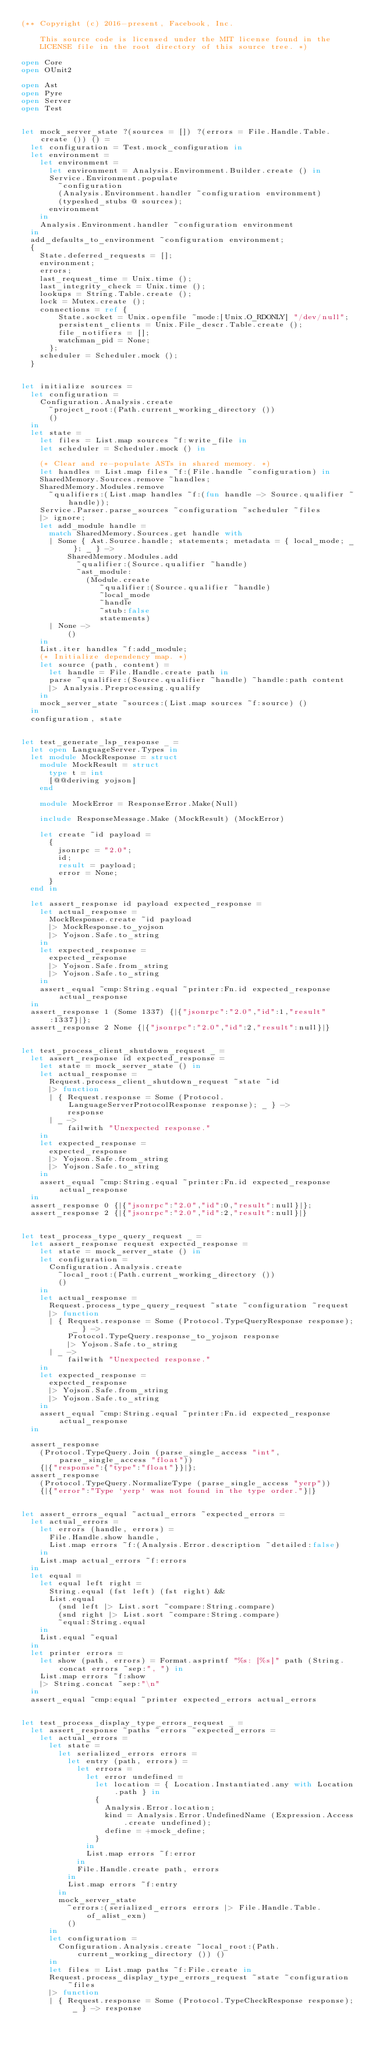<code> <loc_0><loc_0><loc_500><loc_500><_OCaml_>(** Copyright (c) 2016-present, Facebook, Inc.

    This source code is licensed under the MIT license found in the
    LICENSE file in the root directory of this source tree. *)

open Core
open OUnit2

open Ast
open Pyre
open Server
open Test


let mock_server_state ?(sources = []) ?(errors = File.Handle.Table.create ()) () =
  let configuration = Test.mock_configuration in
  let environment =
    let environment =
      let environment = Analysis.Environment.Builder.create () in
      Service.Environment.populate
        ~configuration
        (Analysis.Environment.handler ~configuration environment)
        (typeshed_stubs @ sources);
      environment
    in
    Analysis.Environment.handler ~configuration environment
  in
  add_defaults_to_environment ~configuration environment;
  {
    State.deferred_requests = [];
    environment;
    errors;
    last_request_time = Unix.time ();
    last_integrity_check = Unix.time ();
    lookups = String.Table.create ();
    lock = Mutex.create ();
    connections = ref {
        State.socket = Unix.openfile ~mode:[Unix.O_RDONLY] "/dev/null";
        persistent_clients = Unix.File_descr.Table.create ();
        file_notifiers = [];
        watchman_pid = None;
      };
    scheduler = Scheduler.mock ();
  }


let initialize sources =
  let configuration =
    Configuration.Analysis.create
      ~project_root:(Path.current_working_directory ())
      ()
  in
  let state =
    let files = List.map sources ~f:write_file in
    let scheduler = Scheduler.mock () in

    (* Clear and re-populate ASTs in shared memory. *)
    let handles = List.map files ~f:(File.handle ~configuration) in
    SharedMemory.Sources.remove ~handles;
    SharedMemory.Modules.remove
      ~qualifiers:(List.map handles ~f:(fun handle -> Source.qualifier ~handle));
    Service.Parser.parse_sources ~configuration ~scheduler ~files
    |> ignore;
    let add_module handle =
      match SharedMemory.Sources.get handle with
      | Some { Ast.Source.handle; statements; metadata = { local_mode; _ }; _ } ->
          SharedMemory.Modules.add
            ~qualifier:(Source.qualifier ~handle)
            ~ast_module:
              (Module.create
                 ~qualifier:(Source.qualifier ~handle)
                 ~local_mode
                 ~handle
                 ~stub:false
                 statements)
      | None ->
          ()
    in
    List.iter handles ~f:add_module;
    (* Initialize dependency map. *)
    let source (path, content) =
      let handle = File.Handle.create path in
      parse ~qualifier:(Source.qualifier ~handle) ~handle:path content
      |> Analysis.Preprocessing.qualify
    in
    mock_server_state ~sources:(List.map sources ~f:source) ()
  in
  configuration, state


let test_generate_lsp_response _ =
  let open LanguageServer.Types in
  let module MockResponse = struct
    module MockResult = struct
      type t = int
      [@@deriving yojson]
    end

    module MockError = ResponseError.Make(Null)

    include ResponseMessage.Make (MockResult) (MockError)

    let create ~id payload =
      {
        jsonrpc = "2.0";
        id;
        result = payload;
        error = None;
      }
  end in

  let assert_response id payload expected_response =
    let actual_response =
      MockResponse.create ~id payload
      |> MockResponse.to_yojson
      |> Yojson.Safe.to_string
    in
    let expected_response =
      expected_response
      |> Yojson.Safe.from_string
      |> Yojson.Safe.to_string
    in
    assert_equal ~cmp:String.equal ~printer:Fn.id expected_response actual_response
  in
  assert_response 1 (Some 1337) {|{"jsonrpc":"2.0","id":1,"result":1337}|};
  assert_response 2 None {|{"jsonrpc":"2.0","id":2,"result":null}|}


let test_process_client_shutdown_request _ =
  let assert_response id expected_response =
    let state = mock_server_state () in
    let actual_response =
      Request.process_client_shutdown_request ~state ~id
      |> function
      | { Request.response = Some (Protocol.LanguageServerProtocolResponse response); _ } ->
          response
      | _ ->
          failwith "Unexpected response."
    in
    let expected_response =
      expected_response
      |> Yojson.Safe.from_string
      |> Yojson.Safe.to_string
    in
    assert_equal ~cmp:String.equal ~printer:Fn.id expected_response actual_response
  in
  assert_response 0 {|{"jsonrpc":"2.0","id":0,"result":null}|};
  assert_response 2 {|{"jsonrpc":"2.0","id":2,"result":null}|}


let test_process_type_query_request _ =
  let assert_response request expected_response =
    let state = mock_server_state () in
    let configuration =
      Configuration.Analysis.create
        ~local_root:(Path.current_working_directory ())
        ()
    in
    let actual_response =
      Request.process_type_query_request ~state ~configuration ~request
      |> function
      | { Request.response = Some (Protocol.TypeQueryResponse response); _ } ->
          Protocol.TypeQuery.response_to_yojson response
          |> Yojson.Safe.to_string
      | _ ->
          failwith "Unexpected response."
    in
    let expected_response =
      expected_response
      |> Yojson.Safe.from_string
      |> Yojson.Safe.to_string
    in
    assert_equal ~cmp:String.equal ~printer:Fn.id expected_response actual_response
  in

  assert_response
    (Protocol.TypeQuery.Join (parse_single_access "int", parse_single_access "float"))
    {|{"response":{"type":"float"}}|};
  assert_response
    (Protocol.TypeQuery.NormalizeType (parse_single_access "yerp"))
    {|{"error":"Type `yerp` was not found in the type order."}|}


let assert_errors_equal ~actual_errors ~expected_errors =
  let actual_errors =
    let errors (handle, errors) =
      File.Handle.show handle,
      List.map errors ~f:(Analysis.Error.description ~detailed:false)
    in
    List.map actual_errors ~f:errors
  in
  let equal =
    let equal left right =
      String.equal (fst left) (fst right) &&
      List.equal
        (snd left |> List.sort ~compare:String.compare)
        (snd right |> List.sort ~compare:String.compare)
        ~equal:String.equal
    in
    List.equal ~equal
  in
  let printer errors =
    let show (path, errors) = Format.asprintf "%s: [%s]" path (String.concat errors ~sep:", ") in
    List.map errors ~f:show
    |> String.concat ~sep:"\n"
  in
  assert_equal ~cmp:equal ~printer expected_errors actual_errors


let test_process_display_type_errors_request _ =
  let assert_response ~paths ~errors ~expected_errors =
    let actual_errors =
      let state =
        let serialized_errors errors =
          let entry (path, errors) =
            let errors =
              let error undefined =
                let location = { Location.Instantiated.any with Location.path } in
                {
                  Analysis.Error.location;
                  kind = Analysis.Error.UndefinedName (Expression.Access.create undefined);
                  define = +mock_define;
                }
              in
              List.map errors ~f:error
            in
            File.Handle.create path, errors
          in
          List.map errors ~f:entry
        in
        mock_server_state
          ~errors:(serialized_errors errors |> File.Handle.Table.of_alist_exn)
          ()
      in
      let configuration =
        Configuration.Analysis.create ~local_root:(Path.current_working_directory ()) ()
      in
      let files = List.map paths ~f:File.create in
      Request.process_display_type_errors_request ~state ~configuration ~files
      |> function
      | { Request.response = Some (Protocol.TypeCheckResponse response); _ } -> response</code> 